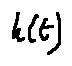<formula> <loc_0><loc_0><loc_500><loc_500>h ( t )</formula> 